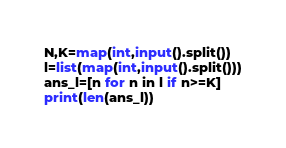<code> <loc_0><loc_0><loc_500><loc_500><_Python_>N,K=map(int,input().split())
l=list(map(int,input().split()))
ans_l=[n for n in l if n>=K]
print(len(ans_l))</code> 